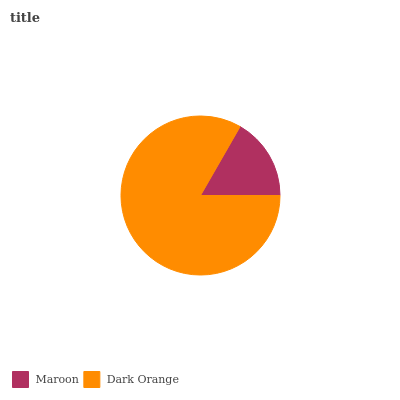Is Maroon the minimum?
Answer yes or no. Yes. Is Dark Orange the maximum?
Answer yes or no. Yes. Is Dark Orange the minimum?
Answer yes or no. No. Is Dark Orange greater than Maroon?
Answer yes or no. Yes. Is Maroon less than Dark Orange?
Answer yes or no. Yes. Is Maroon greater than Dark Orange?
Answer yes or no. No. Is Dark Orange less than Maroon?
Answer yes or no. No. Is Dark Orange the high median?
Answer yes or no. Yes. Is Maroon the low median?
Answer yes or no. Yes. Is Maroon the high median?
Answer yes or no. No. Is Dark Orange the low median?
Answer yes or no. No. 